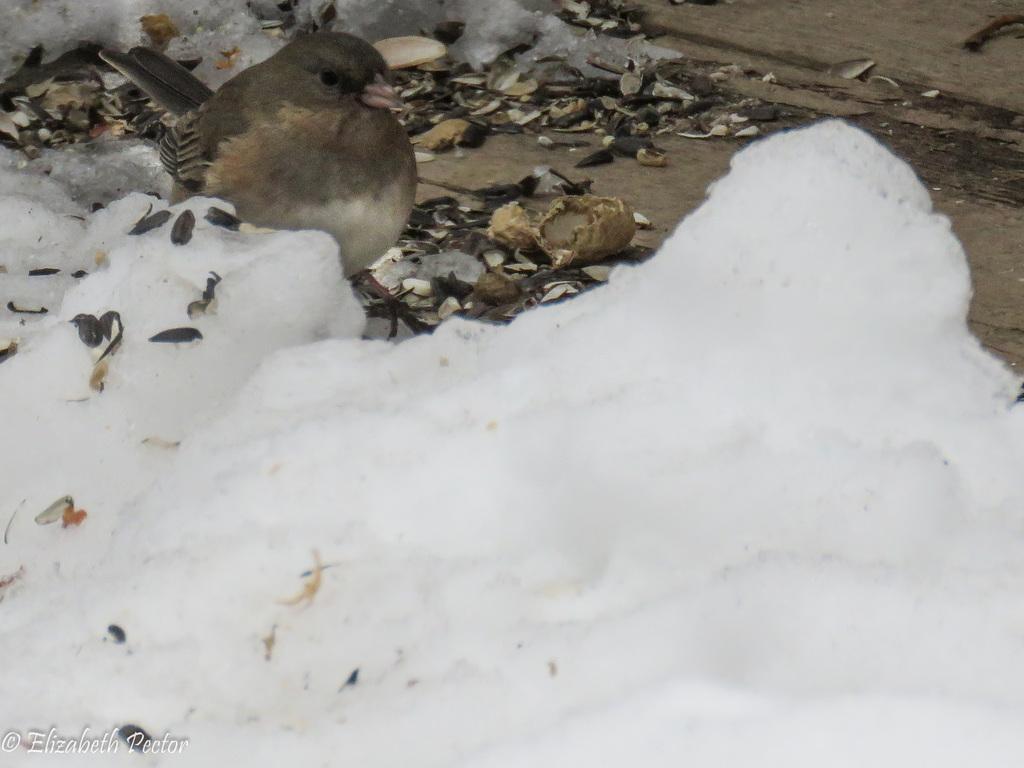Please provide a concise description of this image. In this image I can see the snow, the ground, few objects on the ground and a bird which is grey, black and cream in color. 